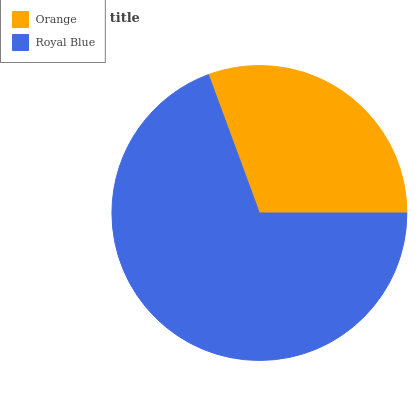Is Orange the minimum?
Answer yes or no. Yes. Is Royal Blue the maximum?
Answer yes or no. Yes. Is Royal Blue the minimum?
Answer yes or no. No. Is Royal Blue greater than Orange?
Answer yes or no. Yes. Is Orange less than Royal Blue?
Answer yes or no. Yes. Is Orange greater than Royal Blue?
Answer yes or no. No. Is Royal Blue less than Orange?
Answer yes or no. No. Is Royal Blue the high median?
Answer yes or no. Yes. Is Orange the low median?
Answer yes or no. Yes. Is Orange the high median?
Answer yes or no. No. Is Royal Blue the low median?
Answer yes or no. No. 